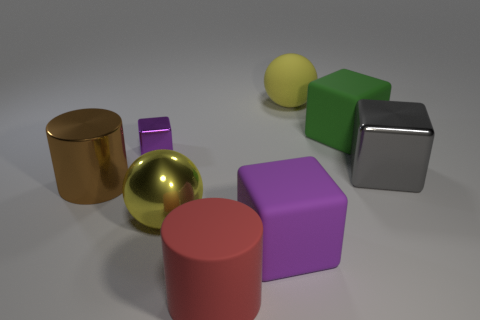What number of other rubber things have the same shape as the big brown object?
Give a very brief answer. 1. Is the big rubber ball the same color as the large metal sphere?
Your response must be concise. Yes. What material is the yellow ball behind the yellow thing on the left side of the large sphere behind the large green matte thing?
Give a very brief answer. Rubber. There is a green object; are there any red matte cylinders behind it?
Ensure brevity in your answer.  No. There is a gray thing that is the same size as the metal cylinder; what shape is it?
Offer a very short reply. Cube. Do the red object and the large green block have the same material?
Keep it short and to the point. Yes. What number of matte things are either cubes or big brown cylinders?
Offer a very short reply. 2. There is a shiny thing that is the same color as the big rubber sphere; what is its shape?
Your answer should be very brief. Sphere. Is the color of the big sphere that is on the left side of the big red rubber object the same as the matte sphere?
Offer a terse response. Yes. There is a rubber object on the left side of the purple block that is on the right side of the tiny thing; what shape is it?
Ensure brevity in your answer.  Cylinder. 